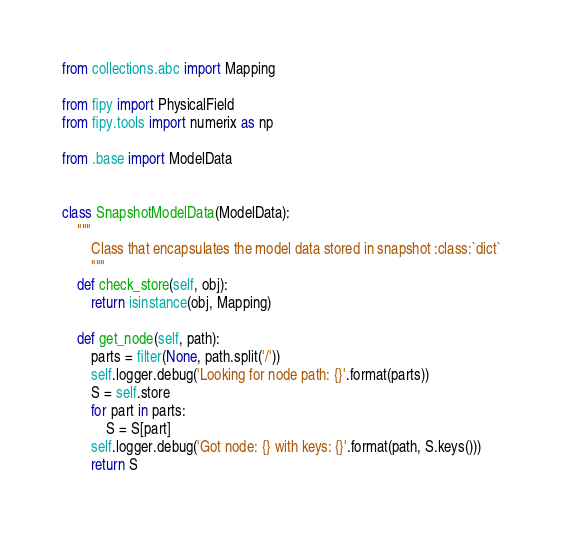<code> <loc_0><loc_0><loc_500><loc_500><_Python_>from collections.abc import Mapping

from fipy import PhysicalField
from fipy.tools import numerix as np

from .base import ModelData


class SnapshotModelData(ModelData):
    """
        Class that encapsulates the model data stored in snapshot :class:`dict`
        """
    def check_store(self, obj):
        return isinstance(obj, Mapping)

    def get_node(self, path):
        parts = filter(None, path.split('/'))
        self.logger.debug('Looking for node path: {}'.format(parts))
        S = self.store
        for part in parts:
            S = S[part]
        self.logger.debug('Got node: {} with keys: {}'.format(path, S.keys()))
        return S
</code> 